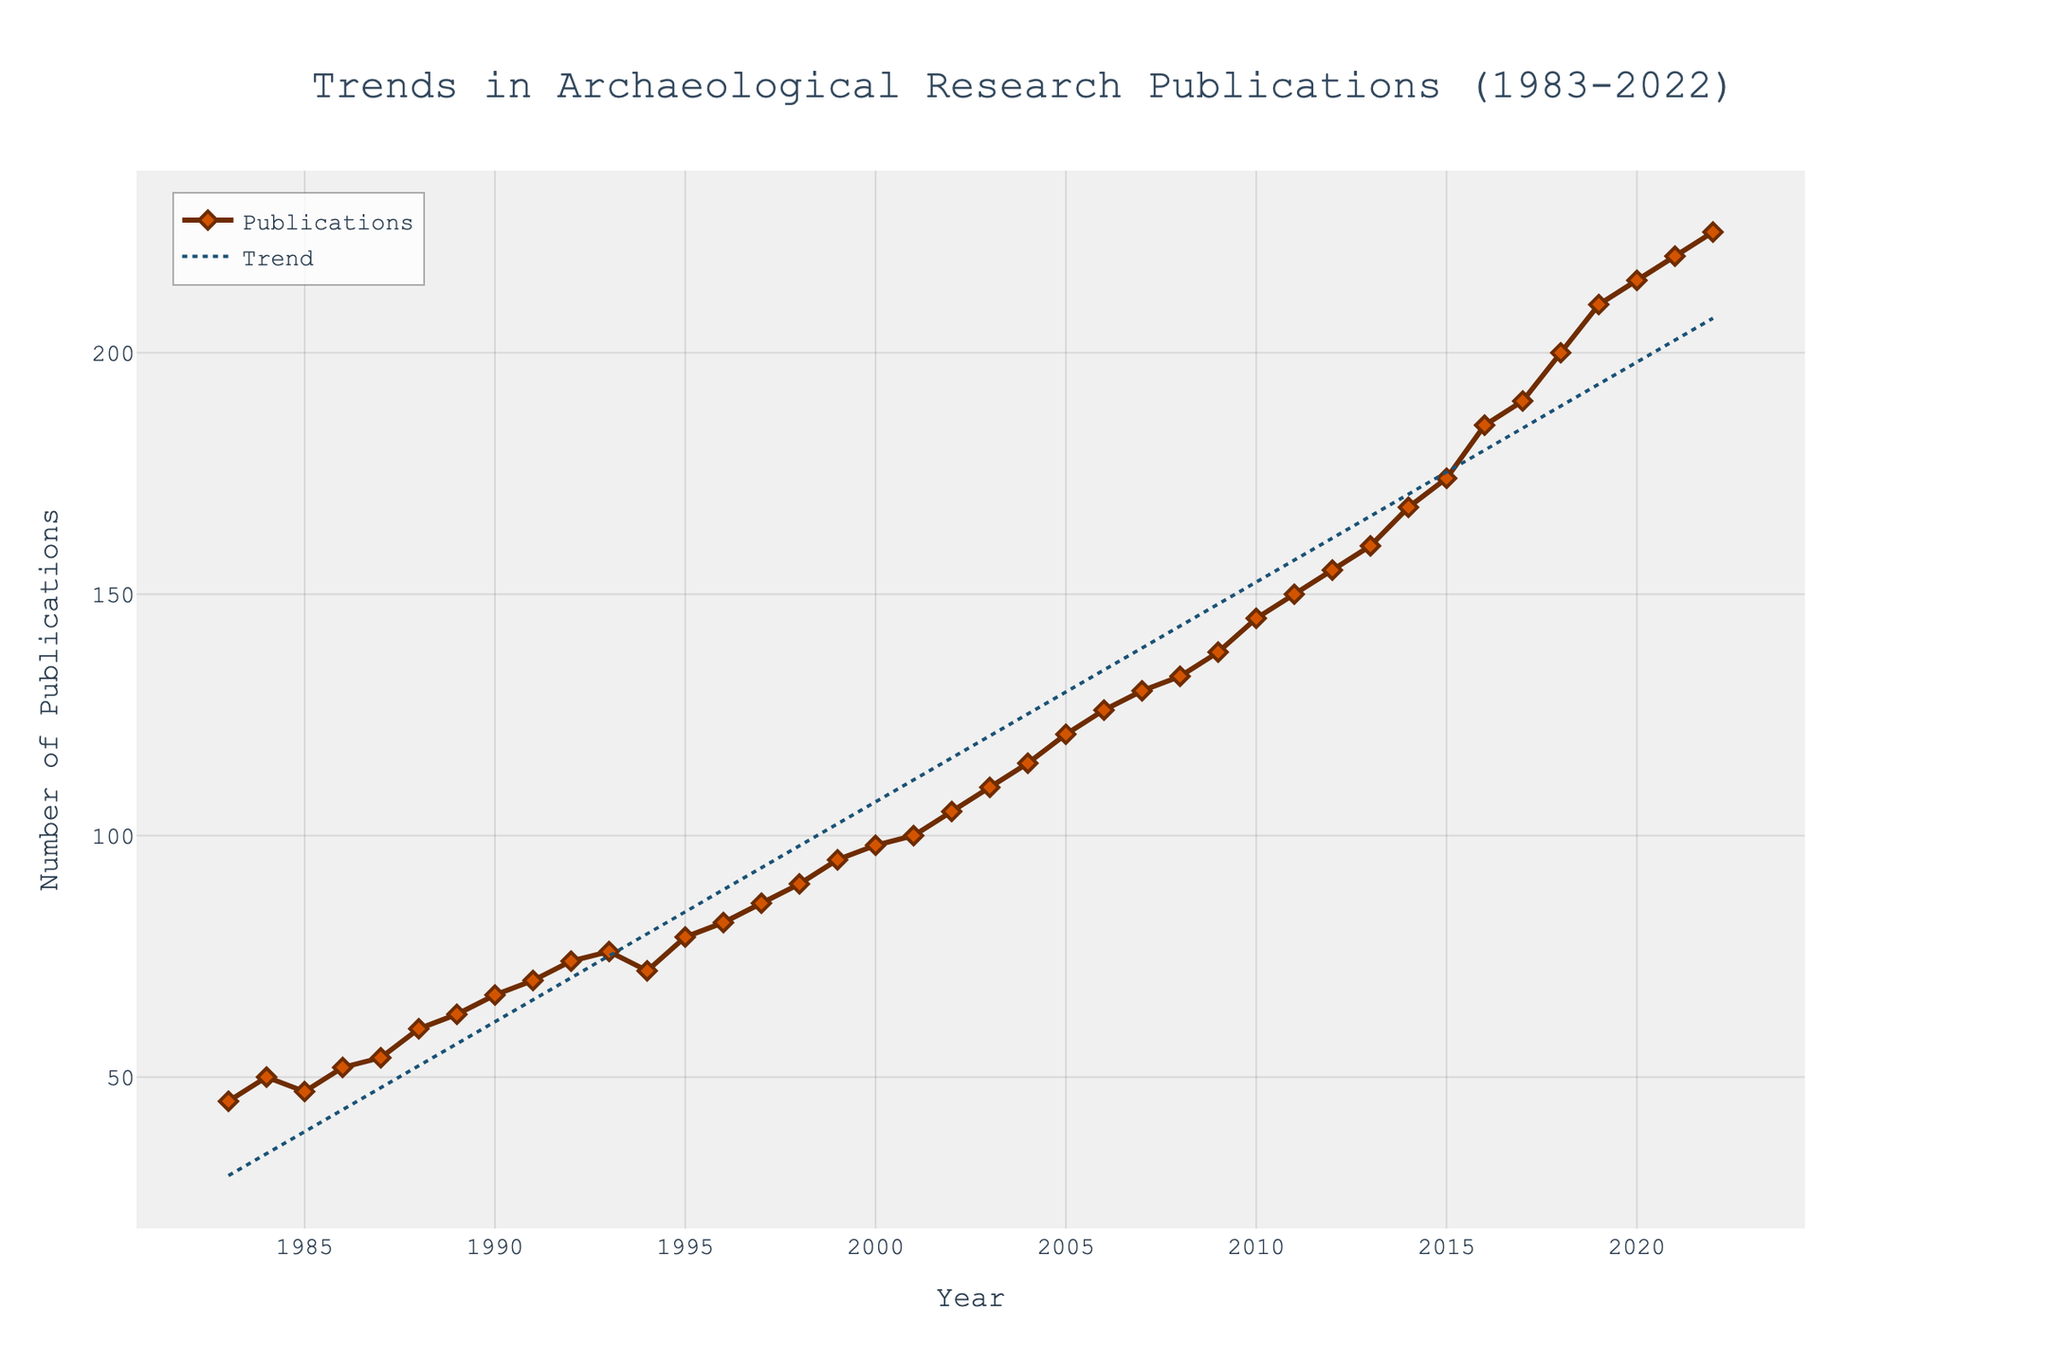What is the title of the plot? The title of the plot is located at the top center of the figure. It reads "Trends in Archaeological Research Publications (1983-2022)"
Answer: Trends in Archaeological Research Publications (1983-2022) What is the y-axis label? The y-axis label is "Number of Publications," which is positioned alongside the vertical axis on the left side of the figure.
Answer: Number of Publications In which year did the number of publications first exceed 100? By observing the data points, the year 2002 is the first time where the number of publications exceeds 100, as shown on the plot.
Answer: 2002 How many publications were recorded in the year 2010? By locating the data point corresponding to the year 2010, it shows the number of publications as 145.
Answer: 145 What is the trend line's color and style? The trend line is represented by a blue dashed line, as seen in the plot's legend and visual representation.
Answer: Blue dashed line In which year did the steepest increase in publications occur, and by how much did it increase from the previous year? Observe the data points year by year and calculate the differences. The largest increase is from 2016 to 2017, where the number went from 185 to 190, an increase of 5.
Answer: 2017, increased by 5 Compare the number of publications in 1983 and 2022. How much has it increased? Subtract the number of publications in 1983 (45) from that in 2022 (225). The increase is 225 - 45 = 180.
Answer: Increased by 180 What is the average number of publications per year over the entire period? Count the total number of years (2022 - 1983 + 1 = 40 years). Sum the total number of publications and divide by the number of years: (45 + 50 + ... + 225) / 40. The average is 113.95.
Answer: 113.95 Visually, how does the trend line compare to the actual data points? The trend line generally follows the upward trajectory of the data points but is smoother and less variable, indicating a consistent upward trend.
Answer: Consistent upward trend What year had a notable drop in publications based on the visual data points? The year 1994 saw a drop in publications compared to 1993, going from 76 to 72.
Answer: 1994 